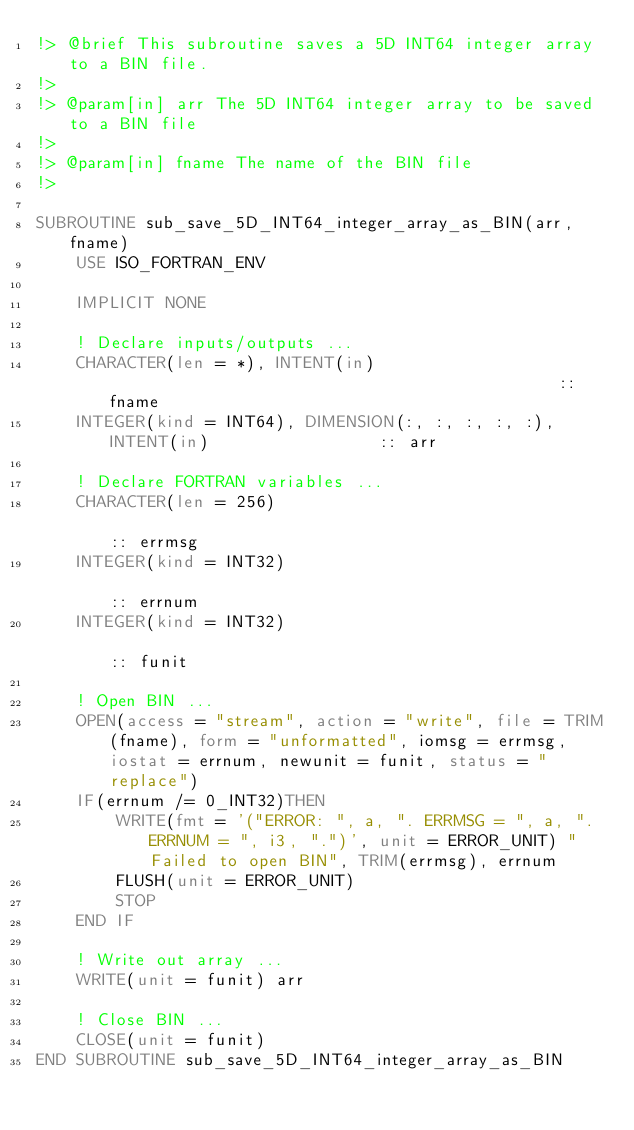<code> <loc_0><loc_0><loc_500><loc_500><_FORTRAN_>!> @brief This subroutine saves a 5D INT64 integer array to a BIN file.
!>
!> @param[in] arr The 5D INT64 integer array to be saved to a BIN file
!>
!> @param[in] fname The name of the BIN file
!>

SUBROUTINE sub_save_5D_INT64_integer_array_as_BIN(arr, fname)
    USE ISO_FORTRAN_ENV

    IMPLICIT NONE

    ! Declare inputs/outputs ...
    CHARACTER(len = *), INTENT(in)                                              :: fname
    INTEGER(kind = INT64), DIMENSION(:, :, :, :, :), INTENT(in)                 :: arr

    ! Declare FORTRAN variables ...
    CHARACTER(len = 256)                                                        :: errmsg
    INTEGER(kind = INT32)                                                       :: errnum
    INTEGER(kind = INT32)                                                       :: funit

    ! Open BIN ...
    OPEN(access = "stream", action = "write", file = TRIM(fname), form = "unformatted", iomsg = errmsg, iostat = errnum, newunit = funit, status = "replace")
    IF(errnum /= 0_INT32)THEN
        WRITE(fmt = '("ERROR: ", a, ". ERRMSG = ", a, ". ERRNUM = ", i3, ".")', unit = ERROR_UNIT) "Failed to open BIN", TRIM(errmsg), errnum
        FLUSH(unit = ERROR_UNIT)
        STOP
    END IF

    ! Write out array ...
    WRITE(unit = funit) arr

    ! Close BIN ...
    CLOSE(unit = funit)
END SUBROUTINE sub_save_5D_INT64_integer_array_as_BIN
</code> 